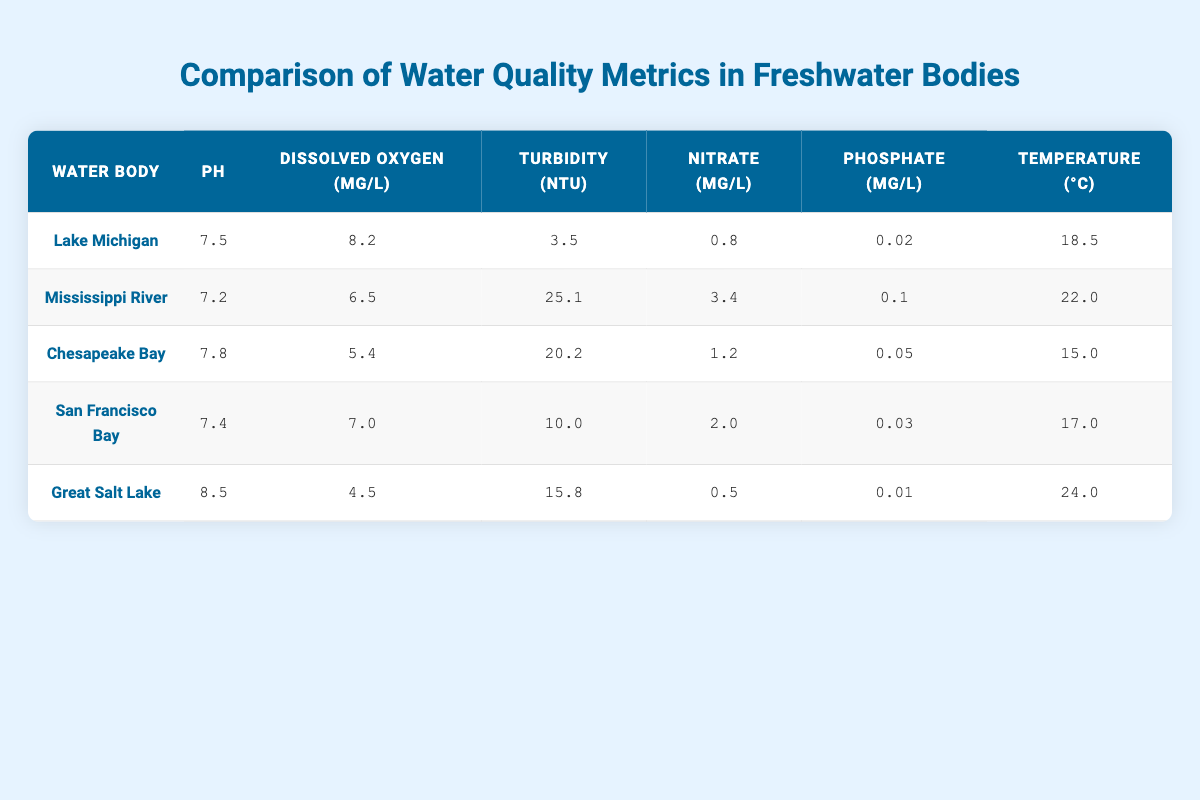What is the pH level of Lake Michigan? The table indicates that the pH level of Lake Michigan is listed in the corresponding row under the "pH" column as 7.5.
Answer: 7.5 Which water body has the highest concentration of nitrate? By checking the "Nitrate (mg/L)" column for all water bodies, the maximum value is found in the Mississippi River row with a concentration of 3.4 mg/L.
Answer: Mississippi River What is the average temperature of all the water bodies listed? Adding the temperatures of all five water bodies: (18.5 + 22.0 + 15.0 + 17.0 + 24.0) = 96.5 degrees Celsius. Then, divide by 5 (the number of water bodies): 96.5 / 5 = 19.3.
Answer: 19.3 Is the dissolved oxygen level in Chesapeake Bay less than that in San Francisco Bay? Comparing the "Dissolved Oxygen (mg/L)" values, Chesapeake Bay has 5.4, while San Francisco Bay has 7.0. Since 5.4 is less than 7.0, the answer is yes.
Answer: Yes Which water body has the lowest turbidity? Looking at the "Turbidity (NTU)" column, Lake Michigan has the lowest value of 3.5 NTU compared to the others listed.
Answer: Lake Michigan What is the difference in phosphate levels between the Great Salt Lake and the Chesapeake Bay? The phosphate level in the Great Salt Lake is 0.01 mg/L and in Chesapeake Bay, it is 0.05 mg/L. The difference is calculated as 0.05 - 0.01 = 0.04 mg/L.
Answer: 0.04 How many water bodies have a dissolved oxygen level above 6 mg/L? By examining the "Dissolved Oxygen (mg/L)" column, only Lake Michigan (8.2 mg/L) and San Francisco Bay (7.0 mg/L) have dissolved oxygen levels above 6 mg/L, totaling two water bodies.
Answer: 2 What is the maximum temperature recorded among the freshwater bodies? Reviewing the "Temperature (°C)" column, the highest value is found in the Great Salt Lake at 24.0 °C, which is more than the others listed.
Answer: 24.0 Is the turbidity in the Mississippi River greater than that in the Great Salt Lake? The turbidity level in the Mississippi River is 25.1 NTU, while that in the Great Salt Lake is 15.8 NTU. Since 25.1 is greater than 15.8, the answer is yes.
Answer: Yes 